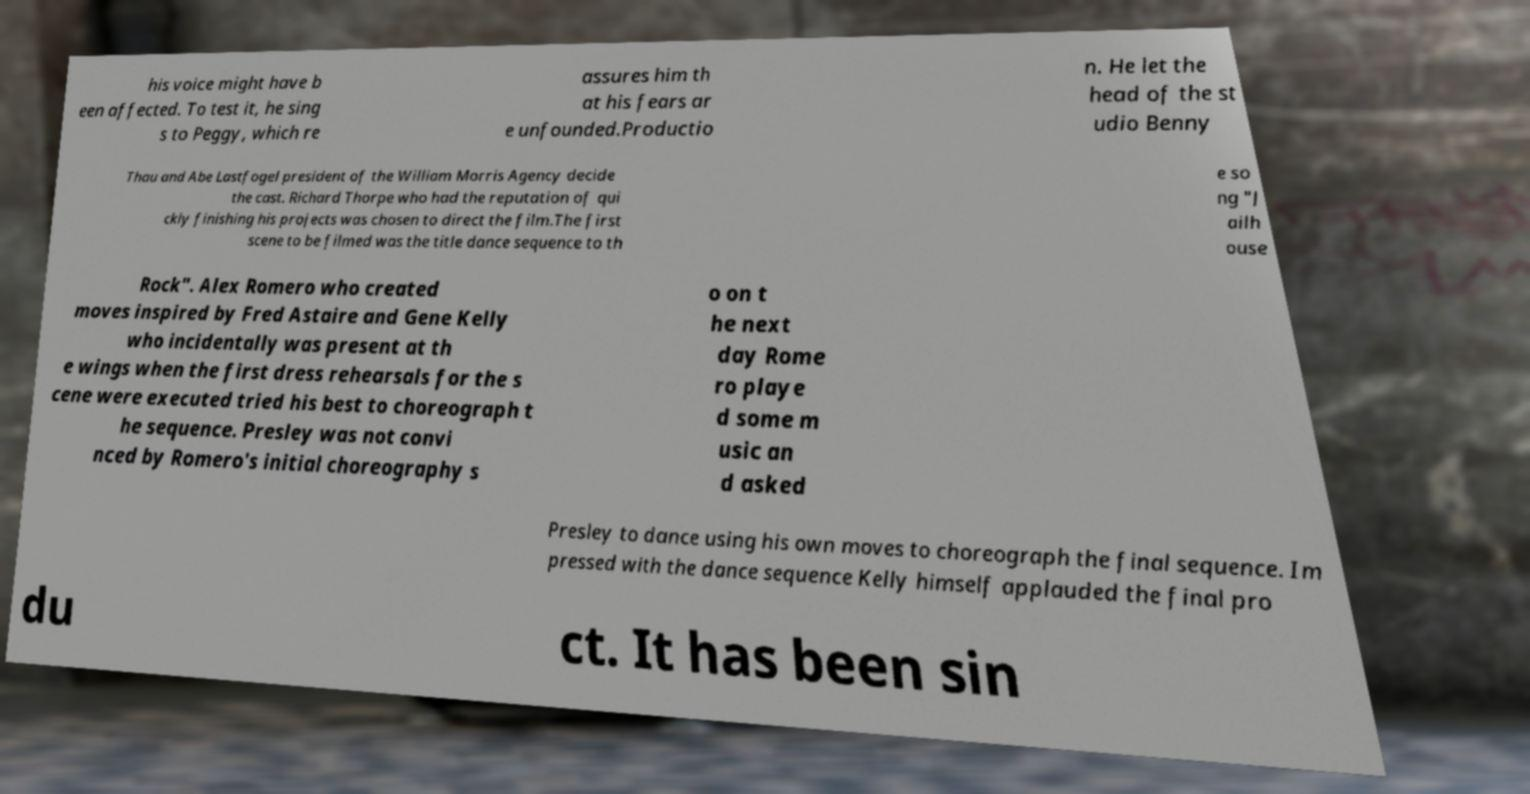Could you extract and type out the text from this image? his voice might have b een affected. To test it, he sing s to Peggy, which re assures him th at his fears ar e unfounded.Productio n. He let the head of the st udio Benny Thau and Abe Lastfogel president of the William Morris Agency decide the cast. Richard Thorpe who had the reputation of qui ckly finishing his projects was chosen to direct the film.The first scene to be filmed was the title dance sequence to th e so ng "J ailh ouse Rock". Alex Romero who created moves inspired by Fred Astaire and Gene Kelly who incidentally was present at th e wings when the first dress rehearsals for the s cene were executed tried his best to choreograph t he sequence. Presley was not convi nced by Romero's initial choreography s o on t he next day Rome ro playe d some m usic an d asked Presley to dance using his own moves to choreograph the final sequence. Im pressed with the dance sequence Kelly himself applauded the final pro du ct. It has been sin 